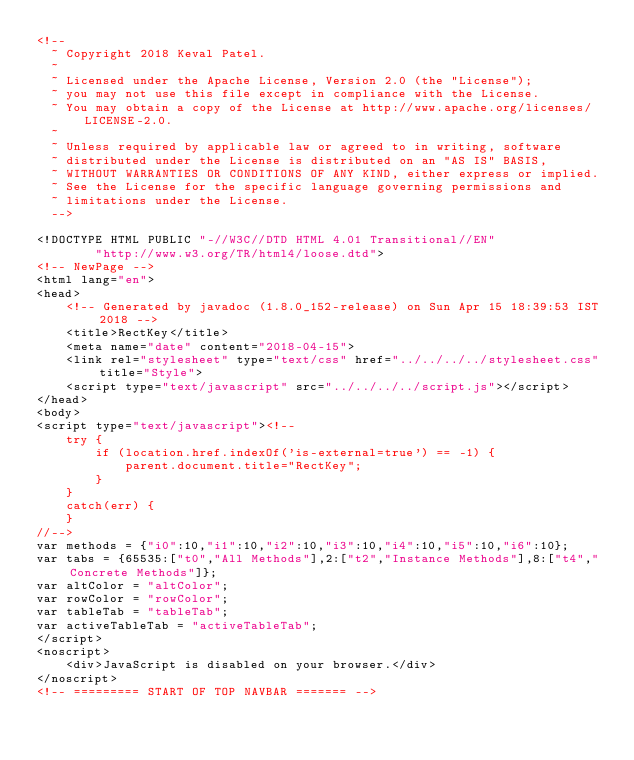Convert code to text. <code><loc_0><loc_0><loc_500><loc_500><_HTML_><!--
  ~ Copyright 2018 Keval Patel.
  ~
  ~ Licensed under the Apache License, Version 2.0 (the "License");
  ~ you may not use this file except in compliance with the License.
  ~ You may obtain a copy of the License at http://www.apache.org/licenses/LICENSE-2.0.
  ~
  ~ Unless required by applicable law or agreed to in writing, software
  ~ distributed under the License is distributed on an "AS IS" BASIS,
  ~ WITHOUT WARRANTIES OR CONDITIONS OF ANY KIND, either express or implied.
  ~ See the License for the specific language governing permissions and
  ~ limitations under the License.
  -->

<!DOCTYPE HTML PUBLIC "-//W3C//DTD HTML 4.01 Transitional//EN"
        "http://www.w3.org/TR/html4/loose.dtd">
<!-- NewPage -->
<html lang="en">
<head>
    <!-- Generated by javadoc (1.8.0_152-release) on Sun Apr 15 18:39:53 IST 2018 -->
    <title>RectKey</title>
    <meta name="date" content="2018-04-15">
    <link rel="stylesheet" type="text/css" href="../../../../stylesheet.css" title="Style">
    <script type="text/javascript" src="../../../../script.js"></script>
</head>
<body>
<script type="text/javascript"><!--
    try {
        if (location.href.indexOf('is-external=true') == -1) {
            parent.document.title="RectKey";
        }
    }
    catch(err) {
    }
//-->
var methods = {"i0":10,"i1":10,"i2":10,"i3":10,"i4":10,"i5":10,"i6":10};
var tabs = {65535:["t0","All Methods"],2:["t2","Instance Methods"],8:["t4","Concrete Methods"]};
var altColor = "altColor";
var rowColor = "rowColor";
var tableTab = "tableTab";
var activeTableTab = "activeTableTab";
</script>
<noscript>
    <div>JavaScript is disabled on your browser.</div>
</noscript>
<!-- ========= START OF TOP NAVBAR ======= --></code> 